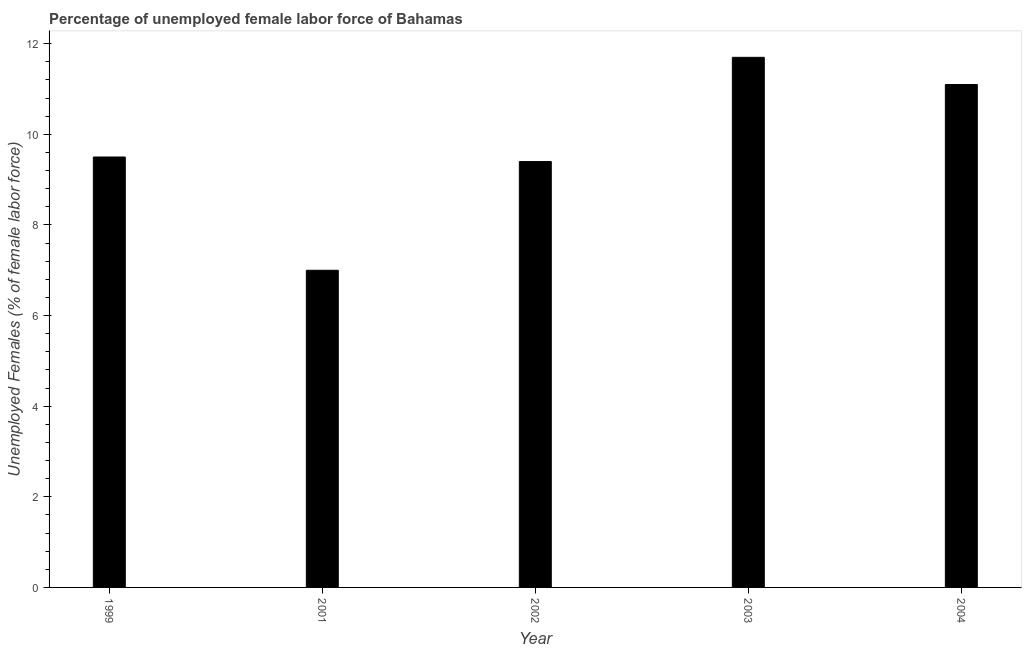Does the graph contain any zero values?
Your answer should be very brief. No. What is the title of the graph?
Offer a very short reply. Percentage of unemployed female labor force of Bahamas. What is the label or title of the X-axis?
Make the answer very short. Year. What is the label or title of the Y-axis?
Your answer should be very brief. Unemployed Females (% of female labor force). What is the total unemployed female labour force in 2001?
Your answer should be very brief. 7. Across all years, what is the maximum total unemployed female labour force?
Make the answer very short. 11.7. Across all years, what is the minimum total unemployed female labour force?
Make the answer very short. 7. In which year was the total unemployed female labour force minimum?
Provide a short and direct response. 2001. What is the sum of the total unemployed female labour force?
Your response must be concise. 48.7. What is the difference between the total unemployed female labour force in 2003 and 2004?
Provide a succinct answer. 0.6. What is the average total unemployed female labour force per year?
Offer a terse response. 9.74. What is the median total unemployed female labour force?
Keep it short and to the point. 9.5. What is the ratio of the total unemployed female labour force in 2001 to that in 2003?
Offer a terse response. 0.6. What is the difference between the highest and the second highest total unemployed female labour force?
Give a very brief answer. 0.6. Is the sum of the total unemployed female labour force in 1999 and 2001 greater than the maximum total unemployed female labour force across all years?
Your answer should be very brief. Yes. What is the difference between the highest and the lowest total unemployed female labour force?
Your answer should be very brief. 4.7. How many bars are there?
Your answer should be very brief. 5. Are the values on the major ticks of Y-axis written in scientific E-notation?
Give a very brief answer. No. What is the Unemployed Females (% of female labor force) in 2002?
Your response must be concise. 9.4. What is the Unemployed Females (% of female labor force) in 2003?
Offer a terse response. 11.7. What is the Unemployed Females (% of female labor force) of 2004?
Ensure brevity in your answer.  11.1. What is the difference between the Unemployed Females (% of female labor force) in 1999 and 2001?
Offer a terse response. 2.5. What is the difference between the Unemployed Females (% of female labor force) in 2001 and 2004?
Your answer should be compact. -4.1. What is the difference between the Unemployed Females (% of female labor force) in 2002 and 2004?
Provide a succinct answer. -1.7. What is the difference between the Unemployed Females (% of female labor force) in 2003 and 2004?
Your answer should be very brief. 0.6. What is the ratio of the Unemployed Females (% of female labor force) in 1999 to that in 2001?
Provide a short and direct response. 1.36. What is the ratio of the Unemployed Females (% of female labor force) in 1999 to that in 2003?
Keep it short and to the point. 0.81. What is the ratio of the Unemployed Females (% of female labor force) in 1999 to that in 2004?
Give a very brief answer. 0.86. What is the ratio of the Unemployed Females (% of female labor force) in 2001 to that in 2002?
Your answer should be compact. 0.74. What is the ratio of the Unemployed Females (% of female labor force) in 2001 to that in 2003?
Make the answer very short. 0.6. What is the ratio of the Unemployed Females (% of female labor force) in 2001 to that in 2004?
Your answer should be very brief. 0.63. What is the ratio of the Unemployed Females (% of female labor force) in 2002 to that in 2003?
Your answer should be compact. 0.8. What is the ratio of the Unemployed Females (% of female labor force) in 2002 to that in 2004?
Provide a succinct answer. 0.85. What is the ratio of the Unemployed Females (% of female labor force) in 2003 to that in 2004?
Keep it short and to the point. 1.05. 